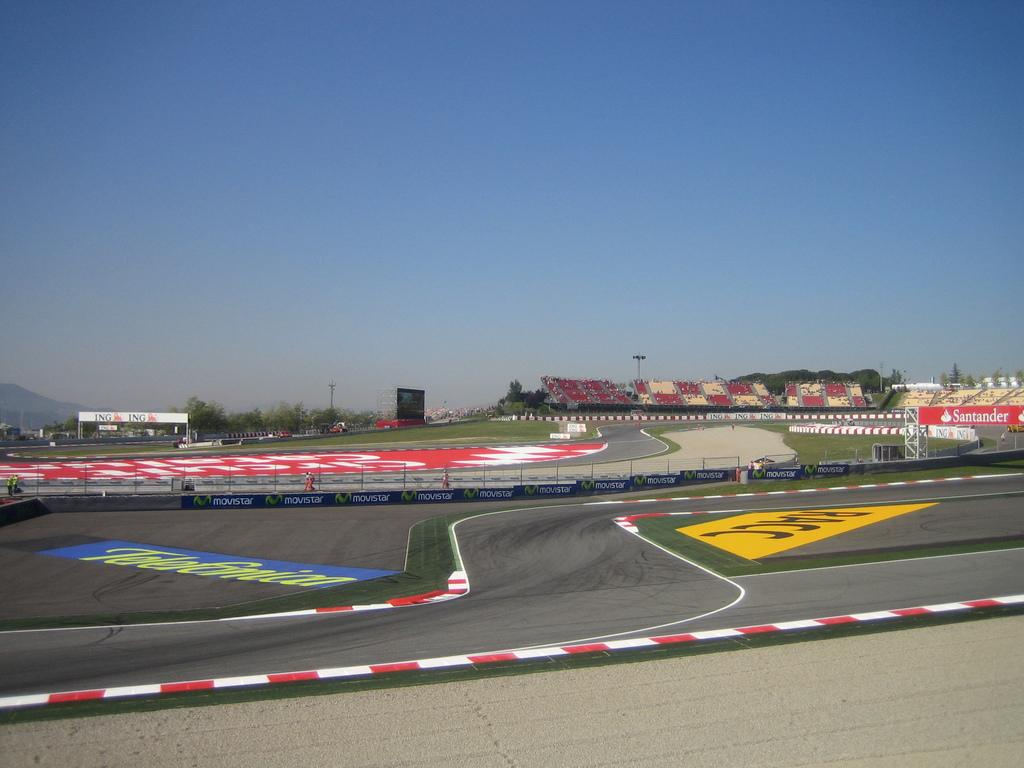What type of infrastructure is present in the image? There are roads in the image. What other objects can be seen in the image? There are boards, poles, and trees visible in the image. What can be seen in the background of the image? There are hills and the sky visible in the background of the image. Can you hear the trees laughing in the image? There are no sounds or actions attributed to the trees in the image, so it is not possible to hear them laughing. 